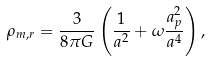<formula> <loc_0><loc_0><loc_500><loc_500>\rho _ { m , r } = \frac { 3 } { 8 \pi G } \left ( \frac { 1 } { a ^ { 2 } } + \omega \frac { a _ { p } ^ { 2 } } { a ^ { 4 } } \right ) ,</formula> 